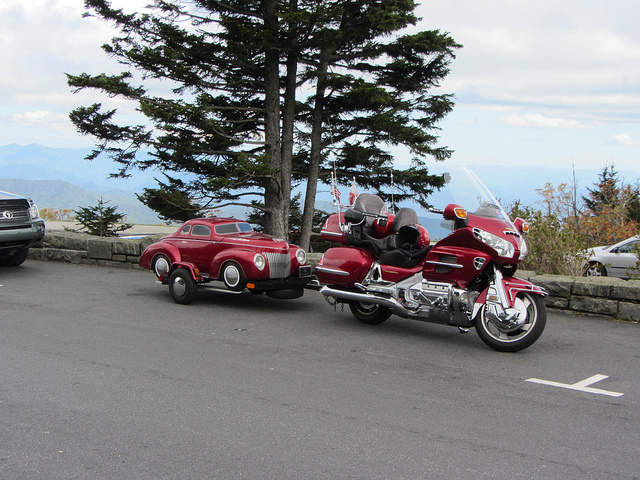Describe the weather and environment in the image. The weather in the image appears to be partially cloudy, with sunlight and shadows playing across the scene. The landscape in the background suggests a cool, temperate climate common in mountainous regions. The environment seems calm with no visible wind or precipitation, making it a pleasant day for an outing or a ride.  Is there anything unique or unusual in this scene? The most unusual aspect of the scene is the small red car, which stands out due to its size and toy-like appearance. It’s definitely not an average vehicle you’d see every day, and it adds a quirky element to the photograph. 